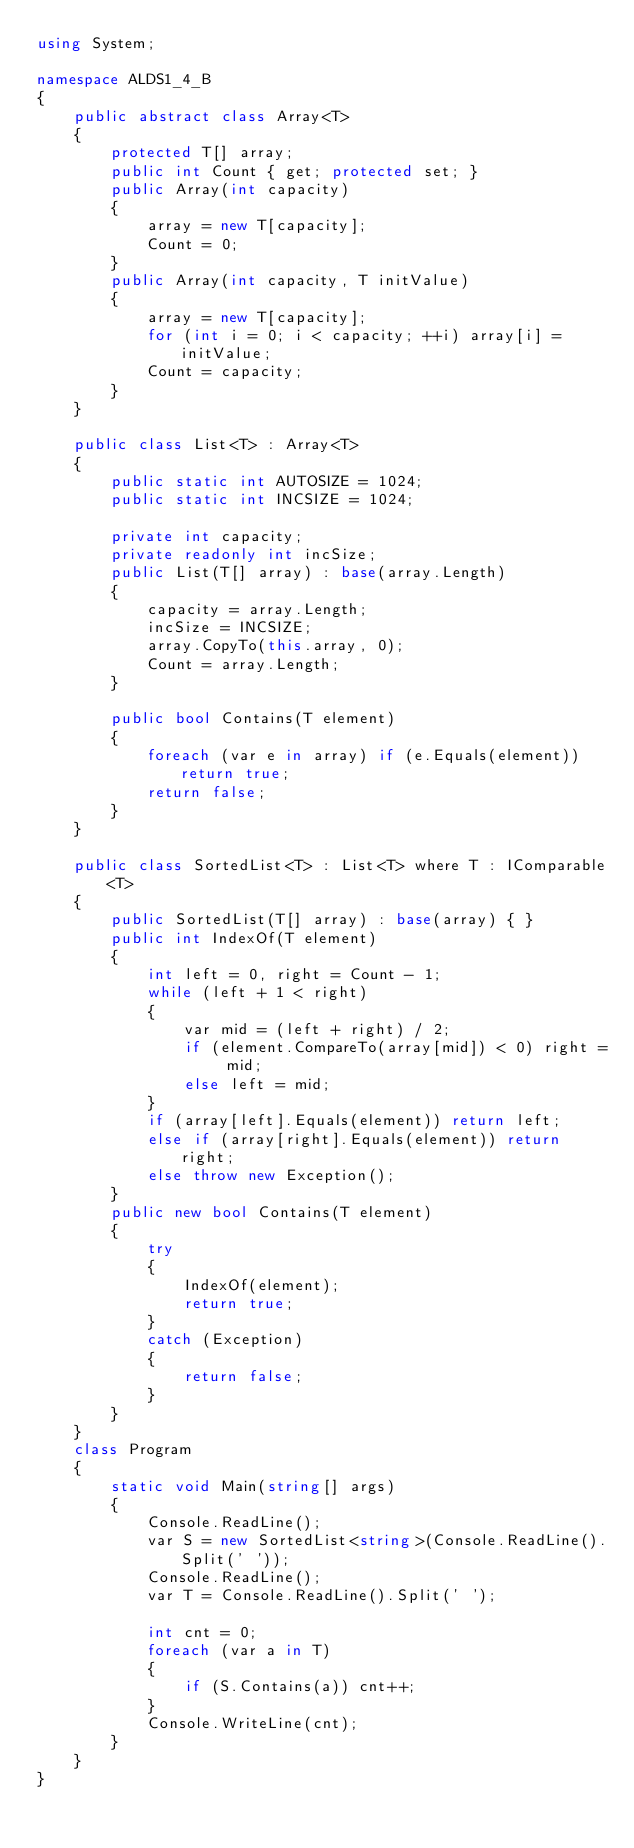<code> <loc_0><loc_0><loc_500><loc_500><_C#_>using System;

namespace ALDS1_4_B
{
    public abstract class Array<T>
    {
        protected T[] array;
        public int Count { get; protected set; }
        public Array(int capacity)
        {
            array = new T[capacity];
            Count = 0;
        }
        public Array(int capacity, T initValue)
        {
            array = new T[capacity];
            for (int i = 0; i < capacity; ++i) array[i] = initValue;
            Count = capacity;
        }
    }

    public class List<T> : Array<T>
    {
        public static int AUTOSIZE = 1024;
        public static int INCSIZE = 1024;

        private int capacity;
        private readonly int incSize;
        public List(T[] array) : base(array.Length)
        {
            capacity = array.Length;
            incSize = INCSIZE;
            array.CopyTo(this.array, 0);
            Count = array.Length;
        }

        public bool Contains(T element)
        {
            foreach (var e in array) if (e.Equals(element)) return true;
            return false;
        }
    }

    public class SortedList<T> : List<T> where T : IComparable<T>
    {
        public SortedList(T[] array) : base(array) { }
        public int IndexOf(T element)
        {
            int left = 0, right = Count - 1;
            while (left + 1 < right)
            {
                var mid = (left + right) / 2;
                if (element.CompareTo(array[mid]) < 0) right = mid;
                else left = mid;
            }
            if (array[left].Equals(element)) return left;
            else if (array[right].Equals(element)) return right;
            else throw new Exception();
        }
        public new bool Contains(T element)
        {
            try
            {
                IndexOf(element);
                return true;
            }
            catch (Exception)
            {
                return false;
            }
        }
    }
    class Program
    {
        static void Main(string[] args)
        {
            Console.ReadLine();
            var S = new SortedList<string>(Console.ReadLine().Split(' '));
            Console.ReadLine();
            var T = Console.ReadLine().Split(' ');

            int cnt = 0;
            foreach (var a in T)
            {
                if (S.Contains(a)) cnt++;
            }
            Console.WriteLine(cnt);
        }
    }
}</code> 